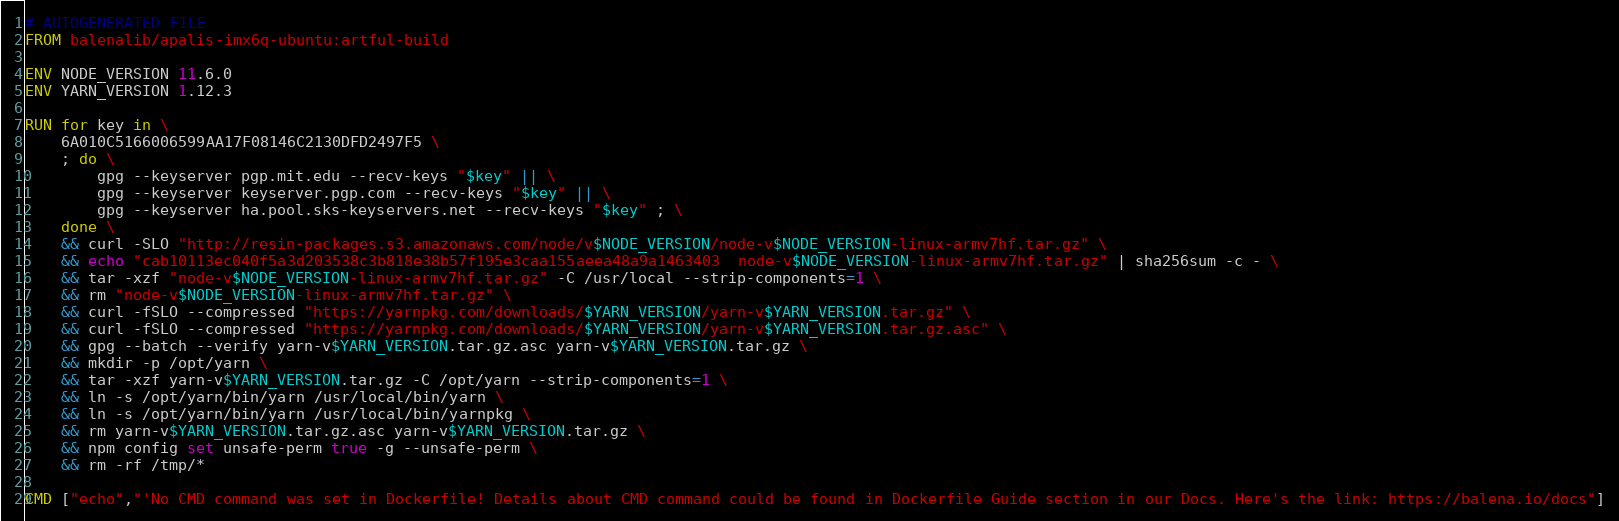Convert code to text. <code><loc_0><loc_0><loc_500><loc_500><_Dockerfile_># AUTOGENERATED FILE
FROM balenalib/apalis-imx6q-ubuntu:artful-build

ENV NODE_VERSION 11.6.0
ENV YARN_VERSION 1.12.3

RUN for key in \
	6A010C5166006599AA17F08146C2130DFD2497F5 \
	; do \
		gpg --keyserver pgp.mit.edu --recv-keys "$key" || \
		gpg --keyserver keyserver.pgp.com --recv-keys "$key" || \
		gpg --keyserver ha.pool.sks-keyservers.net --recv-keys "$key" ; \
	done \
	&& curl -SLO "http://resin-packages.s3.amazonaws.com/node/v$NODE_VERSION/node-v$NODE_VERSION-linux-armv7hf.tar.gz" \
	&& echo "cab10113ec040f5a3d203538c3b818e38b57f195e3caa155aeea48a9a1463403  node-v$NODE_VERSION-linux-armv7hf.tar.gz" | sha256sum -c - \
	&& tar -xzf "node-v$NODE_VERSION-linux-armv7hf.tar.gz" -C /usr/local --strip-components=1 \
	&& rm "node-v$NODE_VERSION-linux-armv7hf.tar.gz" \
	&& curl -fSLO --compressed "https://yarnpkg.com/downloads/$YARN_VERSION/yarn-v$YARN_VERSION.tar.gz" \
	&& curl -fSLO --compressed "https://yarnpkg.com/downloads/$YARN_VERSION/yarn-v$YARN_VERSION.tar.gz.asc" \
	&& gpg --batch --verify yarn-v$YARN_VERSION.tar.gz.asc yarn-v$YARN_VERSION.tar.gz \
	&& mkdir -p /opt/yarn \
	&& tar -xzf yarn-v$YARN_VERSION.tar.gz -C /opt/yarn --strip-components=1 \
	&& ln -s /opt/yarn/bin/yarn /usr/local/bin/yarn \
	&& ln -s /opt/yarn/bin/yarn /usr/local/bin/yarnpkg \
	&& rm yarn-v$YARN_VERSION.tar.gz.asc yarn-v$YARN_VERSION.tar.gz \
	&& npm config set unsafe-perm true -g --unsafe-perm \
	&& rm -rf /tmp/*

CMD ["echo","'No CMD command was set in Dockerfile! Details about CMD command could be found in Dockerfile Guide section in our Docs. Here's the link: https://balena.io/docs"]</code> 